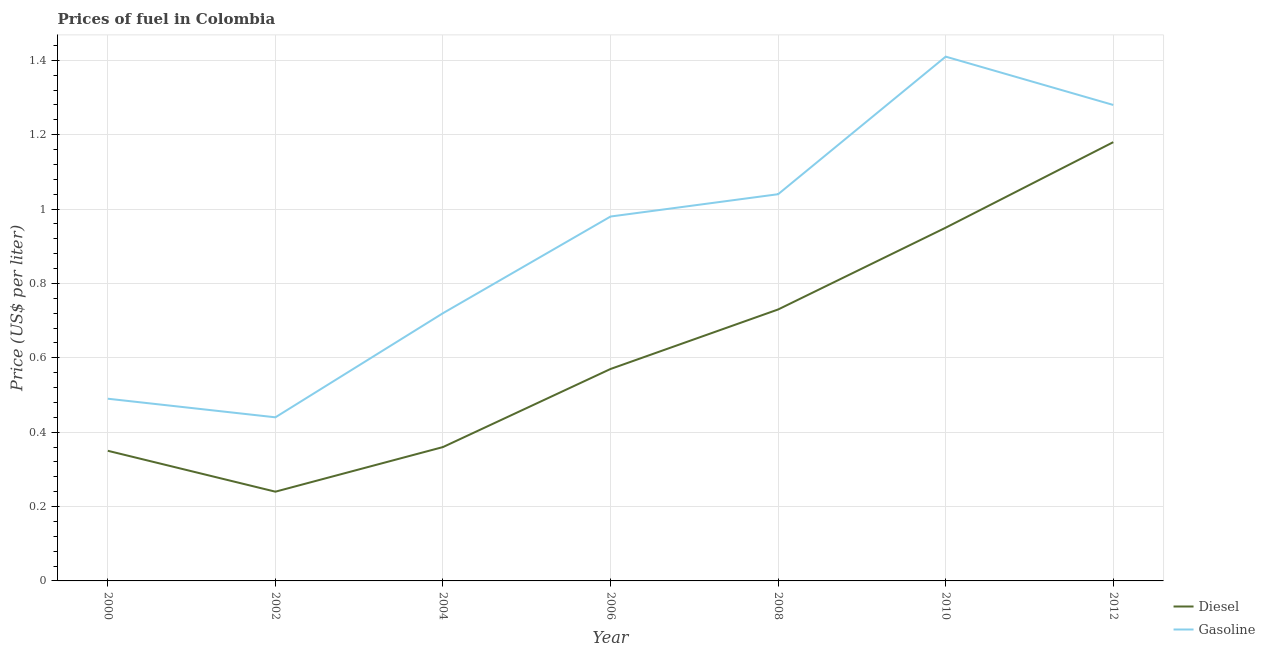How many different coloured lines are there?
Provide a succinct answer. 2. What is the diesel price in 2002?
Provide a succinct answer. 0.24. Across all years, what is the maximum gasoline price?
Give a very brief answer. 1.41. Across all years, what is the minimum gasoline price?
Give a very brief answer. 0.44. In which year was the gasoline price maximum?
Give a very brief answer. 2010. In which year was the gasoline price minimum?
Make the answer very short. 2002. What is the total gasoline price in the graph?
Give a very brief answer. 6.36. What is the difference between the gasoline price in 2004 and that in 2006?
Keep it short and to the point. -0.26. What is the difference between the diesel price in 2004 and the gasoline price in 2008?
Make the answer very short. -0.68. What is the average diesel price per year?
Give a very brief answer. 0.63. In the year 2008, what is the difference between the gasoline price and diesel price?
Give a very brief answer. 0.31. What is the ratio of the gasoline price in 2004 to that in 2008?
Make the answer very short. 0.69. Is the gasoline price in 2000 less than that in 2008?
Offer a terse response. Yes. Is the difference between the gasoline price in 2004 and 2006 greater than the difference between the diesel price in 2004 and 2006?
Offer a very short reply. No. What is the difference between the highest and the second highest gasoline price?
Your answer should be very brief. 0.13. Does the diesel price monotonically increase over the years?
Your answer should be very brief. No. Is the gasoline price strictly greater than the diesel price over the years?
Make the answer very short. Yes. What is the title of the graph?
Provide a short and direct response. Prices of fuel in Colombia. What is the label or title of the X-axis?
Offer a very short reply. Year. What is the label or title of the Y-axis?
Offer a very short reply. Price (US$ per liter). What is the Price (US$ per liter) in Gasoline in 2000?
Offer a very short reply. 0.49. What is the Price (US$ per liter) in Diesel in 2002?
Provide a succinct answer. 0.24. What is the Price (US$ per liter) of Gasoline in 2002?
Provide a short and direct response. 0.44. What is the Price (US$ per liter) in Diesel in 2004?
Offer a very short reply. 0.36. What is the Price (US$ per liter) in Gasoline in 2004?
Your response must be concise. 0.72. What is the Price (US$ per liter) in Diesel in 2006?
Offer a terse response. 0.57. What is the Price (US$ per liter) in Diesel in 2008?
Ensure brevity in your answer.  0.73. What is the Price (US$ per liter) of Diesel in 2010?
Your answer should be very brief. 0.95. What is the Price (US$ per liter) in Gasoline in 2010?
Offer a very short reply. 1.41. What is the Price (US$ per liter) in Diesel in 2012?
Your response must be concise. 1.18. What is the Price (US$ per liter) of Gasoline in 2012?
Offer a terse response. 1.28. Across all years, what is the maximum Price (US$ per liter) in Diesel?
Give a very brief answer. 1.18. Across all years, what is the maximum Price (US$ per liter) in Gasoline?
Make the answer very short. 1.41. Across all years, what is the minimum Price (US$ per liter) of Diesel?
Your answer should be very brief. 0.24. Across all years, what is the minimum Price (US$ per liter) of Gasoline?
Offer a terse response. 0.44. What is the total Price (US$ per liter) of Diesel in the graph?
Keep it short and to the point. 4.38. What is the total Price (US$ per liter) in Gasoline in the graph?
Your answer should be very brief. 6.36. What is the difference between the Price (US$ per liter) of Diesel in 2000 and that in 2002?
Your response must be concise. 0.11. What is the difference between the Price (US$ per liter) of Gasoline in 2000 and that in 2002?
Your answer should be compact. 0.05. What is the difference between the Price (US$ per liter) in Diesel in 2000 and that in 2004?
Your response must be concise. -0.01. What is the difference between the Price (US$ per liter) of Gasoline in 2000 and that in 2004?
Offer a very short reply. -0.23. What is the difference between the Price (US$ per liter) of Diesel in 2000 and that in 2006?
Make the answer very short. -0.22. What is the difference between the Price (US$ per liter) in Gasoline in 2000 and that in 2006?
Your response must be concise. -0.49. What is the difference between the Price (US$ per liter) in Diesel in 2000 and that in 2008?
Your answer should be very brief. -0.38. What is the difference between the Price (US$ per liter) of Gasoline in 2000 and that in 2008?
Offer a terse response. -0.55. What is the difference between the Price (US$ per liter) of Diesel in 2000 and that in 2010?
Your answer should be very brief. -0.6. What is the difference between the Price (US$ per liter) in Gasoline in 2000 and that in 2010?
Provide a succinct answer. -0.92. What is the difference between the Price (US$ per liter) of Diesel in 2000 and that in 2012?
Your answer should be very brief. -0.83. What is the difference between the Price (US$ per liter) in Gasoline in 2000 and that in 2012?
Offer a terse response. -0.79. What is the difference between the Price (US$ per liter) of Diesel in 2002 and that in 2004?
Make the answer very short. -0.12. What is the difference between the Price (US$ per liter) of Gasoline in 2002 and that in 2004?
Give a very brief answer. -0.28. What is the difference between the Price (US$ per liter) in Diesel in 2002 and that in 2006?
Keep it short and to the point. -0.33. What is the difference between the Price (US$ per liter) of Gasoline in 2002 and that in 2006?
Offer a very short reply. -0.54. What is the difference between the Price (US$ per liter) in Diesel in 2002 and that in 2008?
Keep it short and to the point. -0.49. What is the difference between the Price (US$ per liter) in Diesel in 2002 and that in 2010?
Make the answer very short. -0.71. What is the difference between the Price (US$ per liter) of Gasoline in 2002 and that in 2010?
Make the answer very short. -0.97. What is the difference between the Price (US$ per liter) of Diesel in 2002 and that in 2012?
Ensure brevity in your answer.  -0.94. What is the difference between the Price (US$ per liter) in Gasoline in 2002 and that in 2012?
Offer a terse response. -0.84. What is the difference between the Price (US$ per liter) in Diesel in 2004 and that in 2006?
Give a very brief answer. -0.21. What is the difference between the Price (US$ per liter) in Gasoline in 2004 and that in 2006?
Your answer should be compact. -0.26. What is the difference between the Price (US$ per liter) of Diesel in 2004 and that in 2008?
Offer a terse response. -0.37. What is the difference between the Price (US$ per liter) of Gasoline in 2004 and that in 2008?
Your response must be concise. -0.32. What is the difference between the Price (US$ per liter) of Diesel in 2004 and that in 2010?
Provide a succinct answer. -0.59. What is the difference between the Price (US$ per liter) of Gasoline in 2004 and that in 2010?
Provide a succinct answer. -0.69. What is the difference between the Price (US$ per liter) in Diesel in 2004 and that in 2012?
Ensure brevity in your answer.  -0.82. What is the difference between the Price (US$ per liter) in Gasoline in 2004 and that in 2012?
Give a very brief answer. -0.56. What is the difference between the Price (US$ per liter) of Diesel in 2006 and that in 2008?
Your response must be concise. -0.16. What is the difference between the Price (US$ per liter) of Gasoline in 2006 and that in 2008?
Your answer should be compact. -0.06. What is the difference between the Price (US$ per liter) of Diesel in 2006 and that in 2010?
Your response must be concise. -0.38. What is the difference between the Price (US$ per liter) in Gasoline in 2006 and that in 2010?
Your response must be concise. -0.43. What is the difference between the Price (US$ per liter) in Diesel in 2006 and that in 2012?
Offer a terse response. -0.61. What is the difference between the Price (US$ per liter) in Gasoline in 2006 and that in 2012?
Provide a succinct answer. -0.3. What is the difference between the Price (US$ per liter) of Diesel in 2008 and that in 2010?
Make the answer very short. -0.22. What is the difference between the Price (US$ per liter) in Gasoline in 2008 and that in 2010?
Give a very brief answer. -0.37. What is the difference between the Price (US$ per liter) in Diesel in 2008 and that in 2012?
Offer a terse response. -0.45. What is the difference between the Price (US$ per liter) of Gasoline in 2008 and that in 2012?
Make the answer very short. -0.24. What is the difference between the Price (US$ per liter) in Diesel in 2010 and that in 2012?
Provide a succinct answer. -0.23. What is the difference between the Price (US$ per liter) in Gasoline in 2010 and that in 2012?
Give a very brief answer. 0.13. What is the difference between the Price (US$ per liter) of Diesel in 2000 and the Price (US$ per liter) of Gasoline in 2002?
Ensure brevity in your answer.  -0.09. What is the difference between the Price (US$ per liter) of Diesel in 2000 and the Price (US$ per liter) of Gasoline in 2004?
Make the answer very short. -0.37. What is the difference between the Price (US$ per liter) of Diesel in 2000 and the Price (US$ per liter) of Gasoline in 2006?
Make the answer very short. -0.63. What is the difference between the Price (US$ per liter) of Diesel in 2000 and the Price (US$ per liter) of Gasoline in 2008?
Give a very brief answer. -0.69. What is the difference between the Price (US$ per liter) in Diesel in 2000 and the Price (US$ per liter) in Gasoline in 2010?
Make the answer very short. -1.06. What is the difference between the Price (US$ per liter) in Diesel in 2000 and the Price (US$ per liter) in Gasoline in 2012?
Ensure brevity in your answer.  -0.93. What is the difference between the Price (US$ per liter) of Diesel in 2002 and the Price (US$ per liter) of Gasoline in 2004?
Make the answer very short. -0.48. What is the difference between the Price (US$ per liter) in Diesel in 2002 and the Price (US$ per liter) in Gasoline in 2006?
Your answer should be very brief. -0.74. What is the difference between the Price (US$ per liter) of Diesel in 2002 and the Price (US$ per liter) of Gasoline in 2008?
Keep it short and to the point. -0.8. What is the difference between the Price (US$ per liter) in Diesel in 2002 and the Price (US$ per liter) in Gasoline in 2010?
Offer a terse response. -1.17. What is the difference between the Price (US$ per liter) of Diesel in 2002 and the Price (US$ per liter) of Gasoline in 2012?
Provide a short and direct response. -1.04. What is the difference between the Price (US$ per liter) in Diesel in 2004 and the Price (US$ per liter) in Gasoline in 2006?
Make the answer very short. -0.62. What is the difference between the Price (US$ per liter) in Diesel in 2004 and the Price (US$ per liter) in Gasoline in 2008?
Provide a short and direct response. -0.68. What is the difference between the Price (US$ per liter) in Diesel in 2004 and the Price (US$ per liter) in Gasoline in 2010?
Make the answer very short. -1.05. What is the difference between the Price (US$ per liter) of Diesel in 2004 and the Price (US$ per liter) of Gasoline in 2012?
Provide a short and direct response. -0.92. What is the difference between the Price (US$ per liter) in Diesel in 2006 and the Price (US$ per liter) in Gasoline in 2008?
Keep it short and to the point. -0.47. What is the difference between the Price (US$ per liter) of Diesel in 2006 and the Price (US$ per liter) of Gasoline in 2010?
Provide a short and direct response. -0.84. What is the difference between the Price (US$ per liter) of Diesel in 2006 and the Price (US$ per liter) of Gasoline in 2012?
Provide a succinct answer. -0.71. What is the difference between the Price (US$ per liter) of Diesel in 2008 and the Price (US$ per liter) of Gasoline in 2010?
Give a very brief answer. -0.68. What is the difference between the Price (US$ per liter) of Diesel in 2008 and the Price (US$ per liter) of Gasoline in 2012?
Your answer should be very brief. -0.55. What is the difference between the Price (US$ per liter) in Diesel in 2010 and the Price (US$ per liter) in Gasoline in 2012?
Your answer should be very brief. -0.33. What is the average Price (US$ per liter) in Diesel per year?
Ensure brevity in your answer.  0.63. What is the average Price (US$ per liter) of Gasoline per year?
Provide a short and direct response. 0.91. In the year 2000, what is the difference between the Price (US$ per liter) in Diesel and Price (US$ per liter) in Gasoline?
Give a very brief answer. -0.14. In the year 2002, what is the difference between the Price (US$ per liter) of Diesel and Price (US$ per liter) of Gasoline?
Make the answer very short. -0.2. In the year 2004, what is the difference between the Price (US$ per liter) in Diesel and Price (US$ per liter) in Gasoline?
Ensure brevity in your answer.  -0.36. In the year 2006, what is the difference between the Price (US$ per liter) in Diesel and Price (US$ per liter) in Gasoline?
Provide a succinct answer. -0.41. In the year 2008, what is the difference between the Price (US$ per liter) of Diesel and Price (US$ per liter) of Gasoline?
Offer a very short reply. -0.31. In the year 2010, what is the difference between the Price (US$ per liter) of Diesel and Price (US$ per liter) of Gasoline?
Your answer should be very brief. -0.46. What is the ratio of the Price (US$ per liter) of Diesel in 2000 to that in 2002?
Your answer should be compact. 1.46. What is the ratio of the Price (US$ per liter) of Gasoline in 2000 to that in 2002?
Your response must be concise. 1.11. What is the ratio of the Price (US$ per liter) in Diesel in 2000 to that in 2004?
Provide a succinct answer. 0.97. What is the ratio of the Price (US$ per liter) in Gasoline in 2000 to that in 2004?
Your response must be concise. 0.68. What is the ratio of the Price (US$ per liter) of Diesel in 2000 to that in 2006?
Offer a terse response. 0.61. What is the ratio of the Price (US$ per liter) of Diesel in 2000 to that in 2008?
Make the answer very short. 0.48. What is the ratio of the Price (US$ per liter) of Gasoline in 2000 to that in 2008?
Ensure brevity in your answer.  0.47. What is the ratio of the Price (US$ per liter) in Diesel in 2000 to that in 2010?
Your response must be concise. 0.37. What is the ratio of the Price (US$ per liter) of Gasoline in 2000 to that in 2010?
Provide a short and direct response. 0.35. What is the ratio of the Price (US$ per liter) in Diesel in 2000 to that in 2012?
Provide a short and direct response. 0.3. What is the ratio of the Price (US$ per liter) of Gasoline in 2000 to that in 2012?
Keep it short and to the point. 0.38. What is the ratio of the Price (US$ per liter) in Gasoline in 2002 to that in 2004?
Your response must be concise. 0.61. What is the ratio of the Price (US$ per liter) in Diesel in 2002 to that in 2006?
Offer a very short reply. 0.42. What is the ratio of the Price (US$ per liter) in Gasoline in 2002 to that in 2006?
Your answer should be very brief. 0.45. What is the ratio of the Price (US$ per liter) in Diesel in 2002 to that in 2008?
Ensure brevity in your answer.  0.33. What is the ratio of the Price (US$ per liter) in Gasoline in 2002 to that in 2008?
Provide a short and direct response. 0.42. What is the ratio of the Price (US$ per liter) of Diesel in 2002 to that in 2010?
Keep it short and to the point. 0.25. What is the ratio of the Price (US$ per liter) in Gasoline in 2002 to that in 2010?
Keep it short and to the point. 0.31. What is the ratio of the Price (US$ per liter) of Diesel in 2002 to that in 2012?
Your answer should be very brief. 0.2. What is the ratio of the Price (US$ per liter) in Gasoline in 2002 to that in 2012?
Your answer should be compact. 0.34. What is the ratio of the Price (US$ per liter) of Diesel in 2004 to that in 2006?
Provide a succinct answer. 0.63. What is the ratio of the Price (US$ per liter) of Gasoline in 2004 to that in 2006?
Offer a very short reply. 0.73. What is the ratio of the Price (US$ per liter) of Diesel in 2004 to that in 2008?
Your answer should be compact. 0.49. What is the ratio of the Price (US$ per liter) in Gasoline in 2004 to that in 2008?
Your answer should be compact. 0.69. What is the ratio of the Price (US$ per liter) of Diesel in 2004 to that in 2010?
Your answer should be very brief. 0.38. What is the ratio of the Price (US$ per liter) of Gasoline in 2004 to that in 2010?
Provide a short and direct response. 0.51. What is the ratio of the Price (US$ per liter) in Diesel in 2004 to that in 2012?
Provide a short and direct response. 0.31. What is the ratio of the Price (US$ per liter) of Gasoline in 2004 to that in 2012?
Provide a short and direct response. 0.56. What is the ratio of the Price (US$ per liter) of Diesel in 2006 to that in 2008?
Your answer should be compact. 0.78. What is the ratio of the Price (US$ per liter) of Gasoline in 2006 to that in 2008?
Provide a short and direct response. 0.94. What is the ratio of the Price (US$ per liter) of Diesel in 2006 to that in 2010?
Give a very brief answer. 0.6. What is the ratio of the Price (US$ per liter) in Gasoline in 2006 to that in 2010?
Your answer should be very brief. 0.69. What is the ratio of the Price (US$ per liter) in Diesel in 2006 to that in 2012?
Provide a short and direct response. 0.48. What is the ratio of the Price (US$ per liter) of Gasoline in 2006 to that in 2012?
Keep it short and to the point. 0.77. What is the ratio of the Price (US$ per liter) in Diesel in 2008 to that in 2010?
Offer a terse response. 0.77. What is the ratio of the Price (US$ per liter) of Gasoline in 2008 to that in 2010?
Your response must be concise. 0.74. What is the ratio of the Price (US$ per liter) in Diesel in 2008 to that in 2012?
Make the answer very short. 0.62. What is the ratio of the Price (US$ per liter) of Gasoline in 2008 to that in 2012?
Ensure brevity in your answer.  0.81. What is the ratio of the Price (US$ per liter) of Diesel in 2010 to that in 2012?
Keep it short and to the point. 0.81. What is the ratio of the Price (US$ per liter) in Gasoline in 2010 to that in 2012?
Provide a short and direct response. 1.1. What is the difference between the highest and the second highest Price (US$ per liter) in Diesel?
Give a very brief answer. 0.23. What is the difference between the highest and the second highest Price (US$ per liter) in Gasoline?
Your response must be concise. 0.13. What is the difference between the highest and the lowest Price (US$ per liter) of Diesel?
Keep it short and to the point. 0.94. 